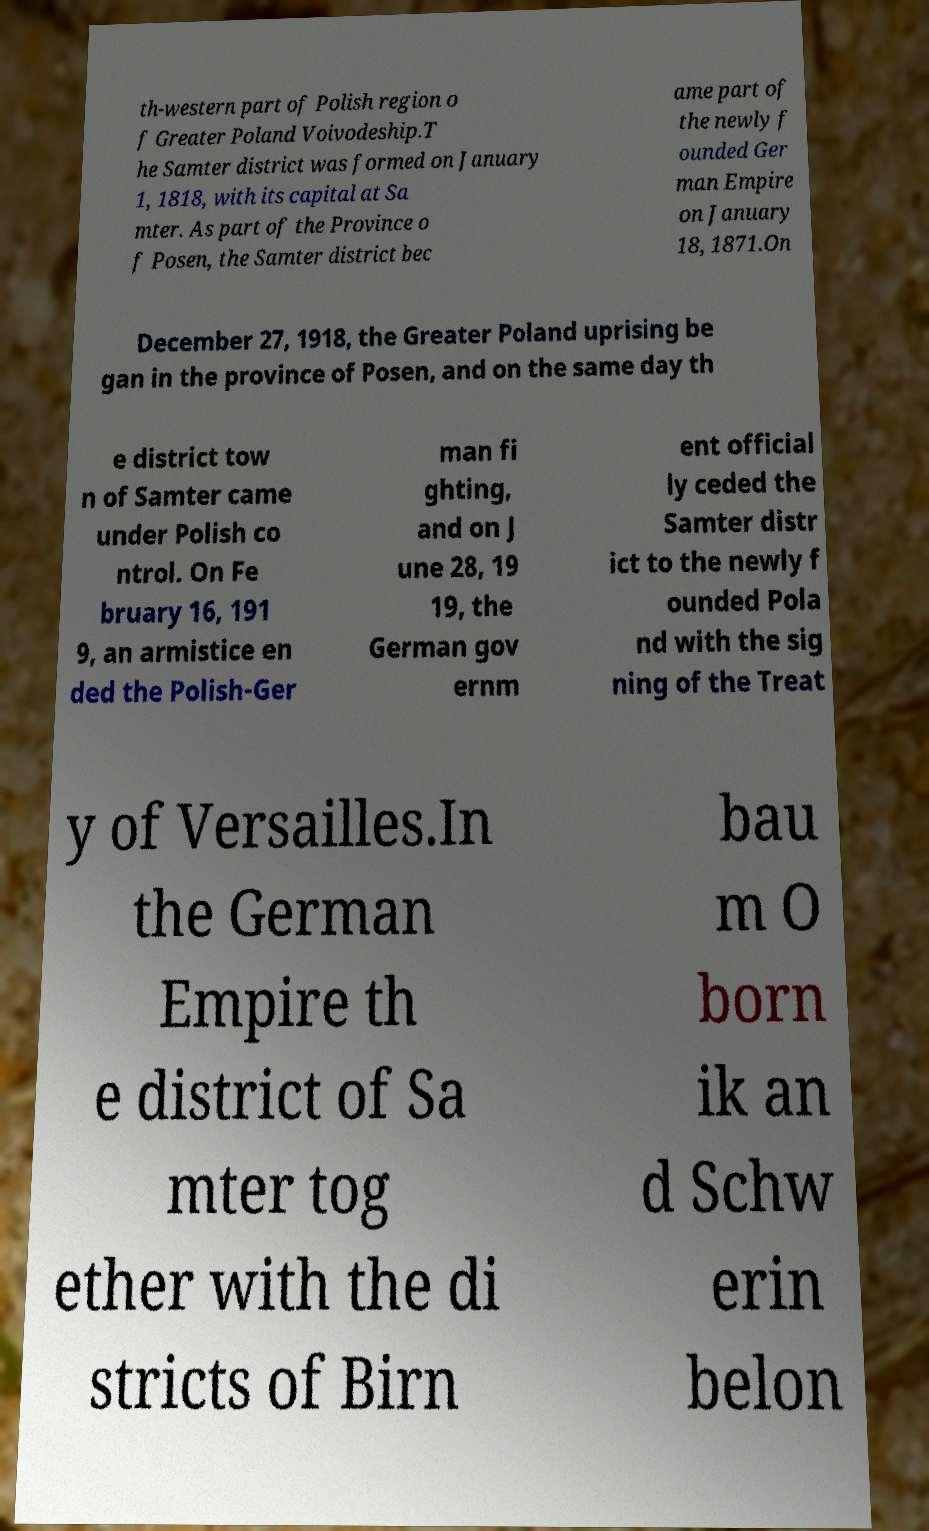There's text embedded in this image that I need extracted. Can you transcribe it verbatim? th-western part of Polish region o f Greater Poland Voivodeship.T he Samter district was formed on January 1, 1818, with its capital at Sa mter. As part of the Province o f Posen, the Samter district bec ame part of the newly f ounded Ger man Empire on January 18, 1871.On December 27, 1918, the Greater Poland uprising be gan in the province of Posen, and on the same day th e district tow n of Samter came under Polish co ntrol. On Fe bruary 16, 191 9, an armistice en ded the Polish-Ger man fi ghting, and on J une 28, 19 19, the German gov ernm ent official ly ceded the Samter distr ict to the newly f ounded Pola nd with the sig ning of the Treat y of Versailles.In the German Empire th e district of Sa mter tog ether with the di stricts of Birn bau m O born ik an d Schw erin belon 